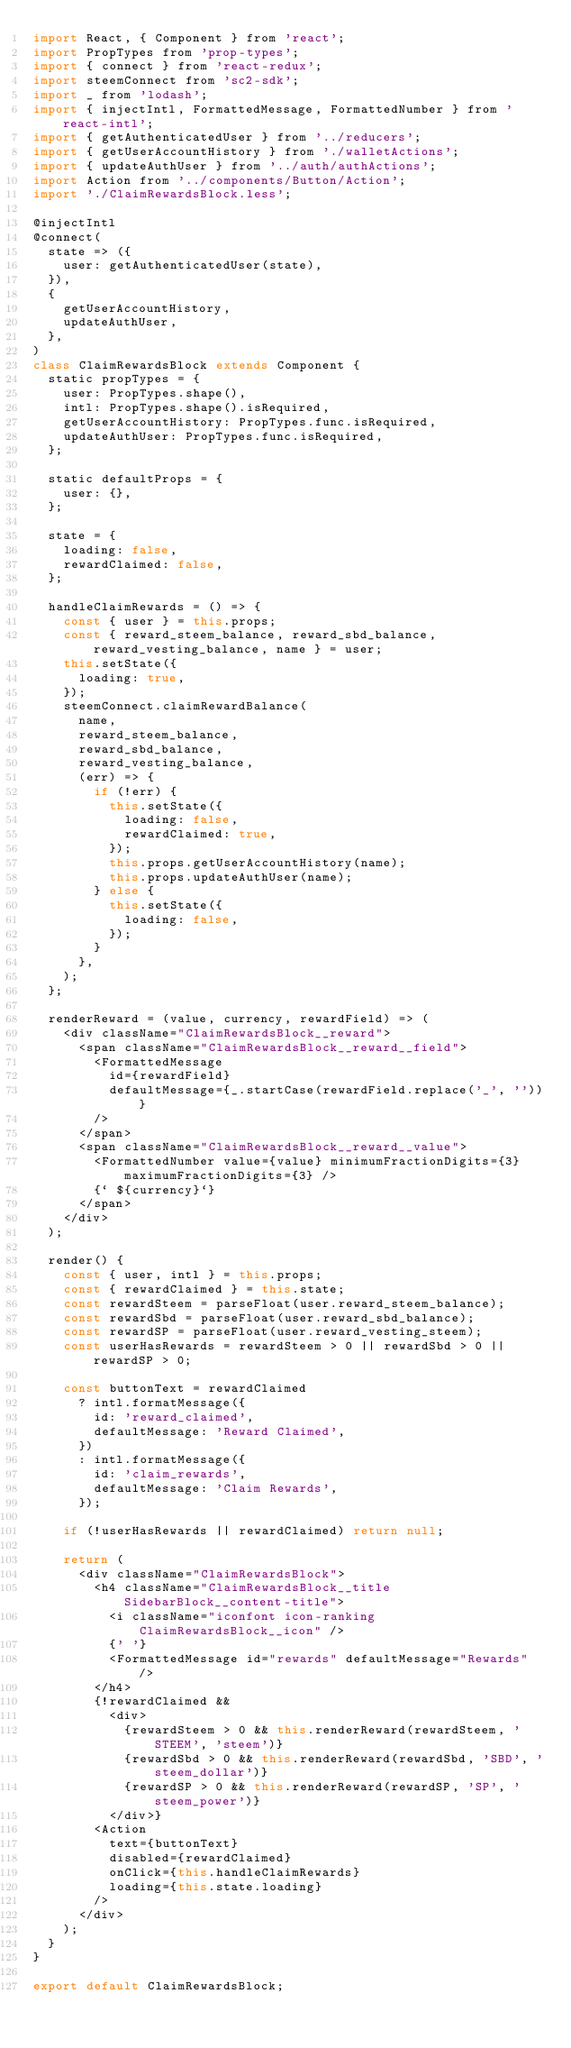Convert code to text. <code><loc_0><loc_0><loc_500><loc_500><_JavaScript_>import React, { Component } from 'react';
import PropTypes from 'prop-types';
import { connect } from 'react-redux';
import steemConnect from 'sc2-sdk';
import _ from 'lodash';
import { injectIntl, FormattedMessage, FormattedNumber } from 'react-intl';
import { getAuthenticatedUser } from '../reducers';
import { getUserAccountHistory } from './walletActions';
import { updateAuthUser } from '../auth/authActions';
import Action from '../components/Button/Action';
import './ClaimRewardsBlock.less';

@injectIntl
@connect(
  state => ({
    user: getAuthenticatedUser(state),
  }),
  {
    getUserAccountHistory,
    updateAuthUser,
  },
)
class ClaimRewardsBlock extends Component {
  static propTypes = {
    user: PropTypes.shape(),
    intl: PropTypes.shape().isRequired,
    getUserAccountHistory: PropTypes.func.isRequired,
    updateAuthUser: PropTypes.func.isRequired,
  };

  static defaultProps = {
    user: {},
  };

  state = {
    loading: false,
    rewardClaimed: false,
  };

  handleClaimRewards = () => {
    const { user } = this.props;
    const { reward_steem_balance, reward_sbd_balance, reward_vesting_balance, name } = user;
    this.setState({
      loading: true,
    });
    steemConnect.claimRewardBalance(
      name,
      reward_steem_balance,
      reward_sbd_balance,
      reward_vesting_balance,
      (err) => {
        if (!err) {
          this.setState({
            loading: false,
            rewardClaimed: true,
          });
          this.props.getUserAccountHistory(name);
          this.props.updateAuthUser(name);
        } else {
          this.setState({
            loading: false,
          });
        }
      },
    );
  };

  renderReward = (value, currency, rewardField) => (
    <div className="ClaimRewardsBlock__reward">
      <span className="ClaimRewardsBlock__reward__field">
        <FormattedMessage
          id={rewardField}
          defaultMessage={_.startCase(rewardField.replace('_', ''))}
        />
      </span>
      <span className="ClaimRewardsBlock__reward__value">
        <FormattedNumber value={value} minimumFractionDigits={3} maximumFractionDigits={3} />
        {` ${currency}`}
      </span>
    </div>
  );

  render() {
    const { user, intl } = this.props;
    const { rewardClaimed } = this.state;
    const rewardSteem = parseFloat(user.reward_steem_balance);
    const rewardSbd = parseFloat(user.reward_sbd_balance);
    const rewardSP = parseFloat(user.reward_vesting_steem);
    const userHasRewards = rewardSteem > 0 || rewardSbd > 0 || rewardSP > 0;

    const buttonText = rewardClaimed
      ? intl.formatMessage({
        id: 'reward_claimed',
        defaultMessage: 'Reward Claimed',
      })
      : intl.formatMessage({
        id: 'claim_rewards',
        defaultMessage: 'Claim Rewards',
      });

    if (!userHasRewards || rewardClaimed) return null;

    return (
      <div className="ClaimRewardsBlock">
        <h4 className="ClaimRewardsBlock__title SidebarBlock__content-title">
          <i className="iconfont icon-ranking ClaimRewardsBlock__icon" />
          {' '}
          <FormattedMessage id="rewards" defaultMessage="Rewards" />
        </h4>
        {!rewardClaimed &&
          <div>
            {rewardSteem > 0 && this.renderReward(rewardSteem, 'STEEM', 'steem')}
            {rewardSbd > 0 && this.renderReward(rewardSbd, 'SBD', 'steem_dollar')}
            {rewardSP > 0 && this.renderReward(rewardSP, 'SP', 'steem_power')}
          </div>}
        <Action
          text={buttonText}
          disabled={rewardClaimed}
          onClick={this.handleClaimRewards}
          loading={this.state.loading}
        />
      </div>
    );
  }
}

export default ClaimRewardsBlock;
</code> 